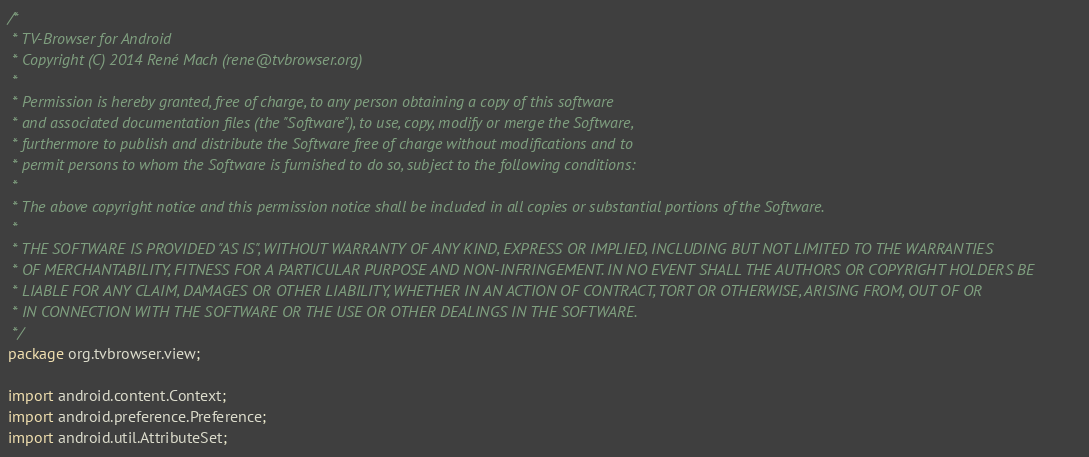<code> <loc_0><loc_0><loc_500><loc_500><_Java_>/*
 * TV-Browser for Android
 * Copyright (C) 2014 René Mach (rene@tvbrowser.org)
 *
 * Permission is hereby granted, free of charge, to any person obtaining a copy of this software
 * and associated documentation files (the "Software"), to use, copy, modify or merge the Software,
 * furthermore to publish and distribute the Software free of charge without modifications and to
 * permit persons to whom the Software is furnished to do so, subject to the following conditions:
 *
 * The above copyright notice and this permission notice shall be included in all copies or substantial portions of the Software.
 *
 * THE SOFTWARE IS PROVIDED "AS IS", WITHOUT WARRANTY OF ANY KIND, EXPRESS OR IMPLIED, INCLUDING BUT NOT LIMITED TO THE WARRANTIES
 * OF MERCHANTABILITY, FITNESS FOR A PARTICULAR PURPOSE AND NON-INFRINGEMENT. IN NO EVENT SHALL THE AUTHORS OR COPYRIGHT HOLDERS BE
 * LIABLE FOR ANY CLAIM, DAMAGES OR OTHER LIABILITY, WHETHER IN AN ACTION OF CONTRACT, TORT OR OTHERWISE, ARISING FROM, OUT OF OR
 * IN CONNECTION WITH THE SOFTWARE OR THE USE OR OTHER DEALINGS IN THE SOFTWARE.
 */
package org.tvbrowser.view;

import android.content.Context;
import android.preference.Preference;
import android.util.AttributeSet;</code> 